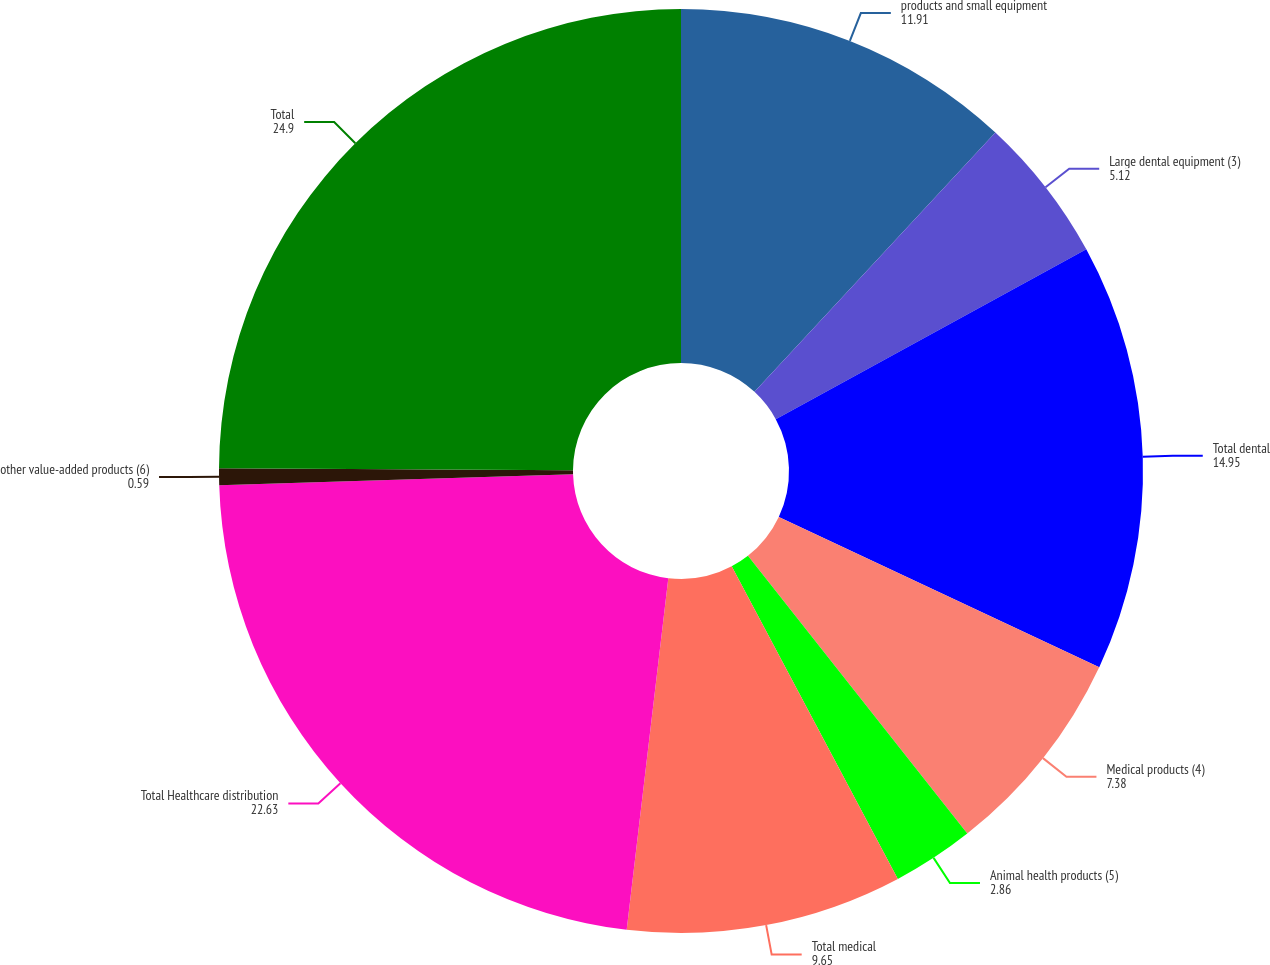Convert chart to OTSL. <chart><loc_0><loc_0><loc_500><loc_500><pie_chart><fcel>products and small equipment<fcel>Large dental equipment (3)<fcel>Total dental<fcel>Medical products (4)<fcel>Animal health products (5)<fcel>Total medical<fcel>Total Healthcare distribution<fcel>other value-added products (6)<fcel>Total<nl><fcel>11.91%<fcel>5.12%<fcel>14.95%<fcel>7.38%<fcel>2.86%<fcel>9.65%<fcel>22.63%<fcel>0.59%<fcel>24.9%<nl></chart> 